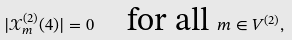Convert formula to latex. <formula><loc_0><loc_0><loc_500><loc_500>| \mathcal { X } _ { m } ^ { ( 2 ) } ( 4 ) | = 0 \quad \text {for all } m \in { V ^ { ( 2 ) } } ,</formula> 